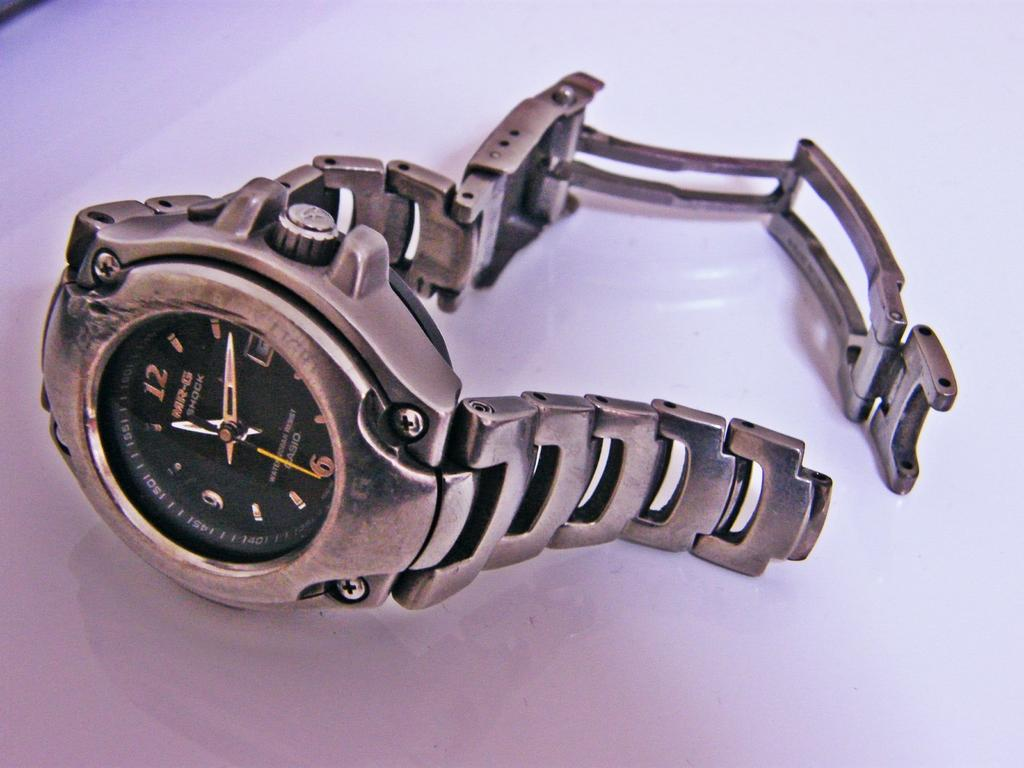<image>
Write a terse but informative summary of the picture. Silver watch with the number 12 on top of the face. 